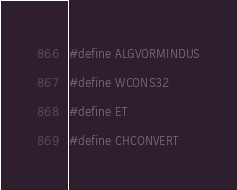Convert code to text. <code><loc_0><loc_0><loc_500><loc_500><_C_>#define ALGVORMINDUS
#define WCONS32
#define ET
#define CHCONVERT
</code> 